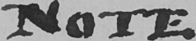Can you read and transcribe this handwriting? NOTE 